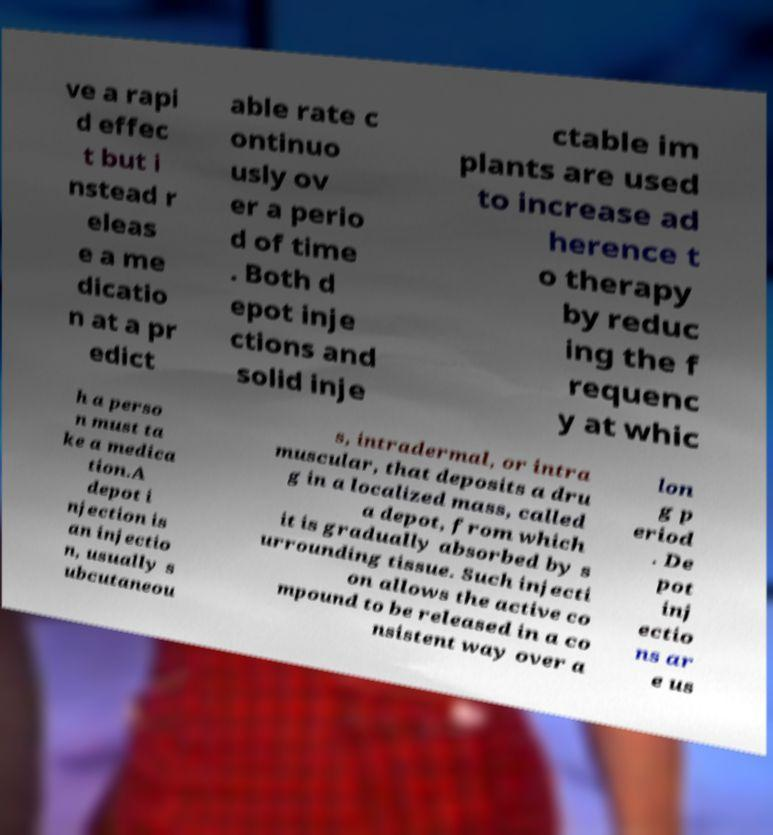What messages or text are displayed in this image? I need them in a readable, typed format. ve a rapi d effec t but i nstead r eleas e a me dicatio n at a pr edict able rate c ontinuo usly ov er a perio d of time . Both d epot inje ctions and solid inje ctable im plants are used to increase ad herence t o therapy by reduc ing the f requenc y at whic h a perso n must ta ke a medica tion.A depot i njection is an injectio n, usually s ubcutaneou s, intradermal, or intra muscular, that deposits a dru g in a localized mass, called a depot, from which it is gradually absorbed by s urrounding tissue. Such injecti on allows the active co mpound to be released in a co nsistent way over a lon g p eriod . De pot inj ectio ns ar e us 